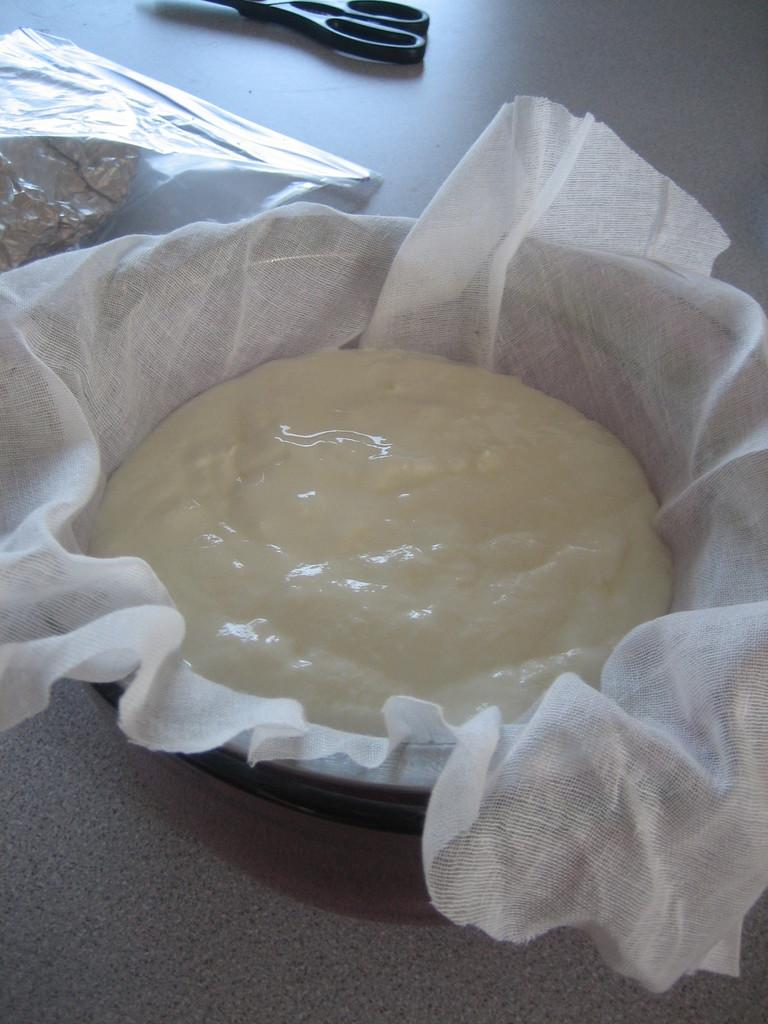What is in the bowl that is visible in the picture? There is an item in a bowl in the picture. What is the bowl placed on? The bowl is placed on a white cloth. What other material is present in the image? There is an aluminum foil in the image. What object can be seen on the floor in the image? There are scissors on the floor in the image. What type of clouds can be seen in the image? There are no clouds present in the image. What is the pan used for in the image? There is no pan present in the image. 